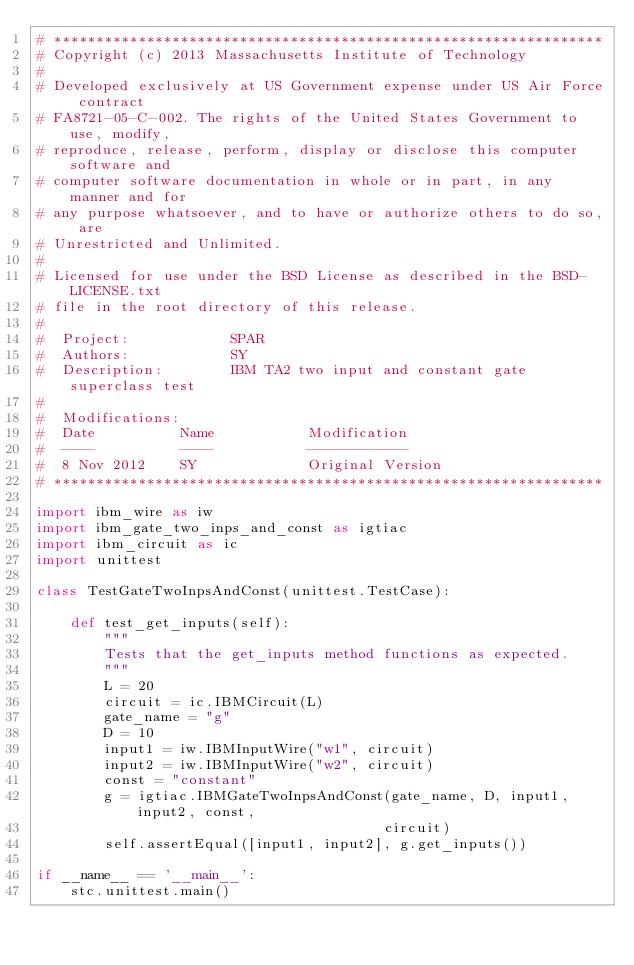Convert code to text. <code><loc_0><loc_0><loc_500><loc_500><_Python_># *****************************************************************
# Copyright (c) 2013 Massachusetts Institute of Technology
#
# Developed exclusively at US Government expense under US Air Force contract
# FA8721-05-C-002. The rights of the United States Government to use, modify,
# reproduce, release, perform, display or disclose this computer software and
# computer software documentation in whole or in part, in any manner and for
# any purpose whatsoever, and to have or authorize others to do so, are
# Unrestricted and Unlimited.
#
# Licensed for use under the BSD License as described in the BSD-LICENSE.txt
# file in the root directory of this release.
#  
#  Project:            SPAR
#  Authors:            SY
#  Description:        IBM TA2 two input and constant gate superclass test 
# 
#  Modifications:
#  Date          Name           Modification
#  ----          ----           ------------
#  8 Nov 2012    SY             Original Version
# *****************************************************************

import ibm_wire as iw
import ibm_gate_two_inps_and_const as igtiac
import ibm_circuit as ic
import unittest

class TestGateTwoInpsAndConst(unittest.TestCase):

    def test_get_inputs(self):
        """
        Tests that the get_inputs method functions as expected.
        """
        L = 20
        circuit = ic.IBMCircuit(L)
        gate_name = "g"
        D = 10
        input1 = iw.IBMInputWire("w1", circuit)
        input2 = iw.IBMInputWire("w2", circuit)
        const = "constant"
        g = igtiac.IBMGateTwoInpsAndConst(gate_name, D, input1, input2, const,
                                         circuit)
        self.assertEqual([input1, input2], g.get_inputs())

if __name__ == '__main__':
    stc.unittest.main()

</code> 